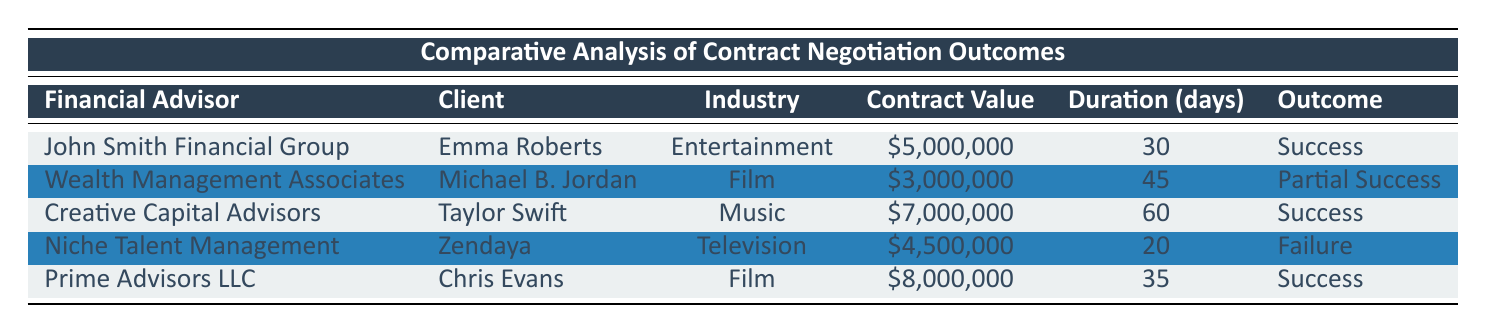What is the contract value for Emma Roberts? Referring to the table, the row corresponding to Emma Roberts indicates that the contract value is 5,000,000.
Answer: 5,000,000 How many days did it take to negotiate Michael B. Jordan's contract? The table shows the negotiation duration for Michael B. Jordan as 45 days.
Answer: 45 What was the final outcome of Zendaya's contract negotiation? Looking at the table, Zendaya's contract outcome is marked as "Failure."
Answer: Failure Which financial advisor negotiated the highest contract value? By examining the contract values, Prime Advisors LLC negotiated the highest contract value of 8,000,000.
Answer: Prime Advisors LLC What is the average contract value across all clients? The contract values are 5,000,000, 3,000,000, 7,000,000, 4,500,000, and 8,000,000. The sum is 27,500,000, and there are 5 contracts, so the average is 27,500,000 / 5 = 5,500,000.
Answer: 5,500,000 Did Creative Capital Advisors achieve a successful outcome? Checking the outcome in the table, Creative Capital Advisors' negotiation with Taylor Swift resulted in a "Success."
Answer: Yes Is there an entry in the table showing a failure in contract negotiations? Yes, the table lists Zendaya's negotiation as a "Failure."
Answer: Yes How many clients had a successful negotiation compared to those who did not? From the table, 3 contracts (Emma Roberts, Taylor Swift, Chris Evans) were successful and 2 (Michael B. Jordan, Zendaya) were not, so there are more successful negotiations.
Answer: More successful negotiations What additional benefit was secured for Taylor Swift? The table indicates that Taylor Swift's negotiation resulted in securing "Merchandising rights."
Answer: Merchandising rights 